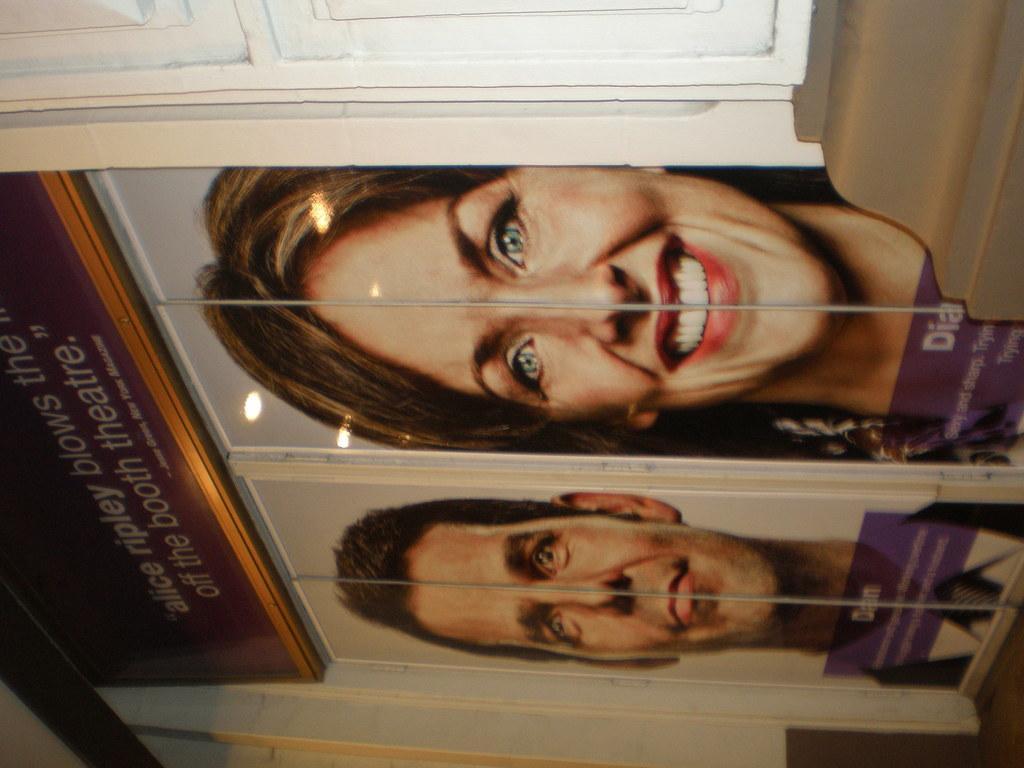Could you give a brief overview of what you see in this image? In this image there is a wall, to that wall there are two doors on that doors there are pictures of a man and women, on the top there is some text. 